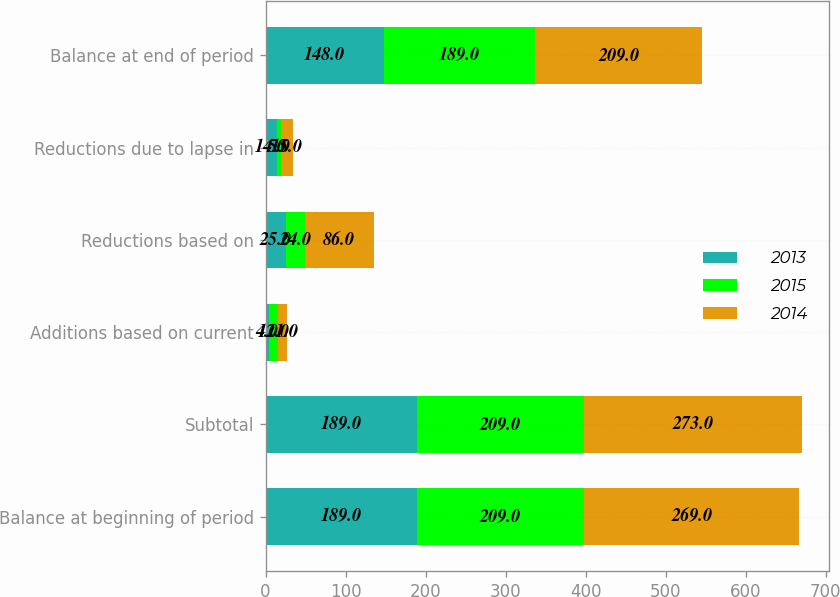<chart> <loc_0><loc_0><loc_500><loc_500><stacked_bar_chart><ecel><fcel>Balance at beginning of period<fcel>Subtotal<fcel>Additions based on current<fcel>Reductions based on<fcel>Reductions due to lapse in<fcel>Balance at end of period<nl><fcel>2013<fcel>189<fcel>189<fcel>4<fcel>25<fcel>14<fcel>148<nl><fcel>2015<fcel>209<fcel>209<fcel>12<fcel>24<fcel>5<fcel>189<nl><fcel>2014<fcel>269<fcel>273<fcel>11<fcel>86<fcel>15<fcel>209<nl></chart> 